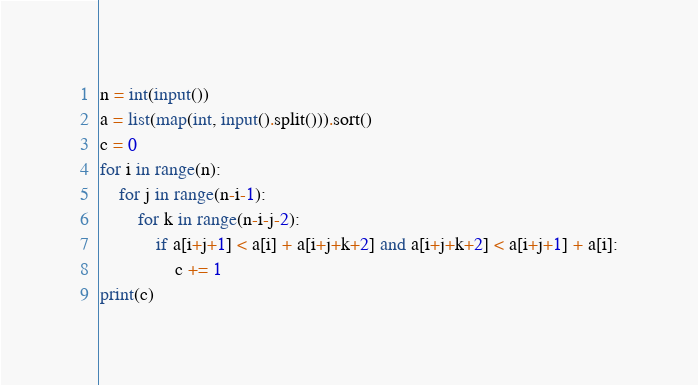Convert code to text. <code><loc_0><loc_0><loc_500><loc_500><_Python_>n = int(input())
a = list(map(int, input().split())).sort()
c = 0
for i in range(n):
    for j in range(n-i-1):
        for k in range(n-i-j-2):
            if a[i+j+1] < a[i] + a[i+j+k+2] and a[i+j+k+2] < a[i+j+1] + a[i]:
                c += 1
print(c)
</code> 